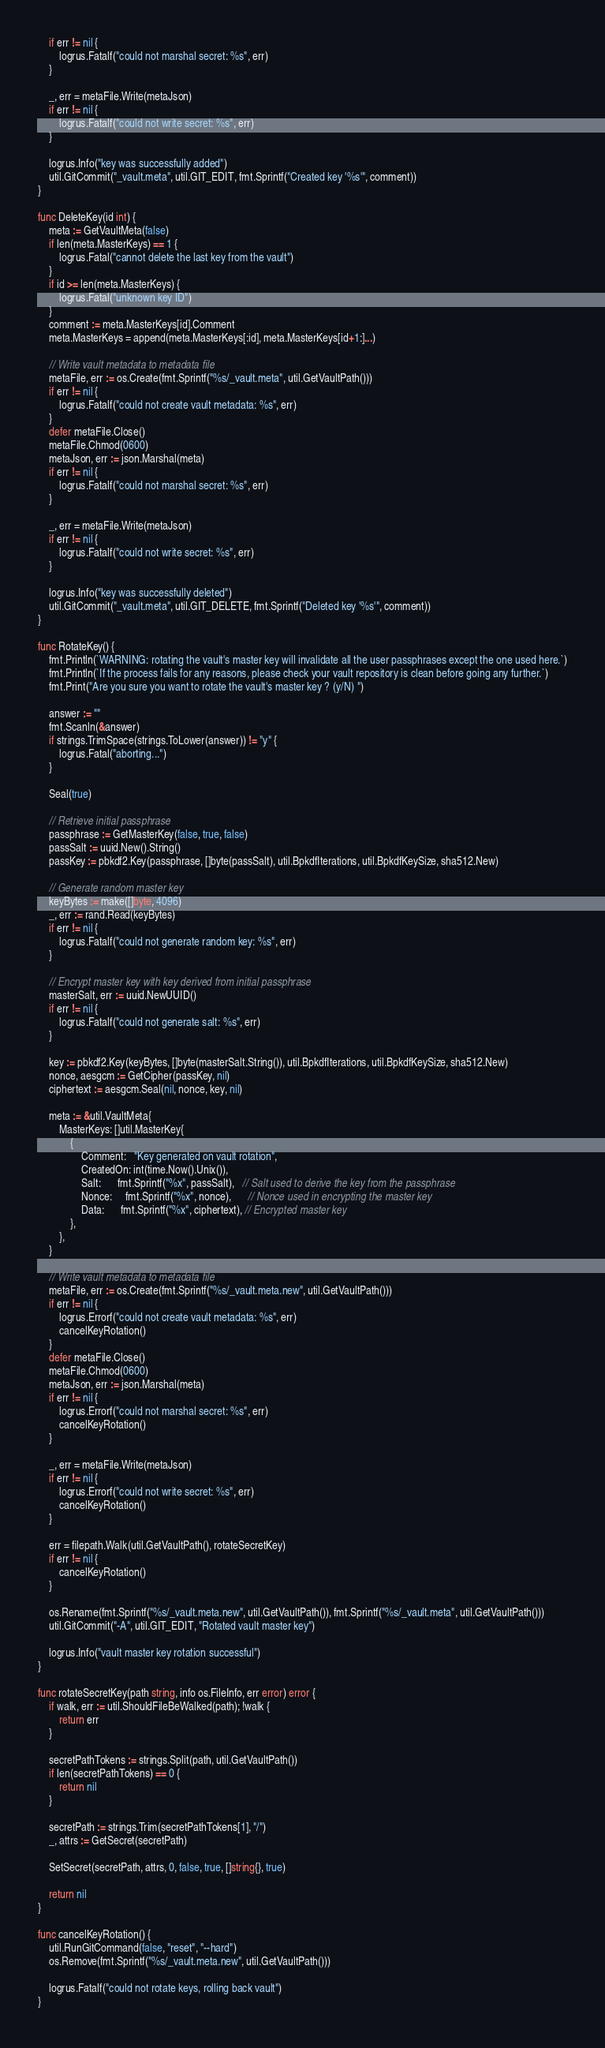<code> <loc_0><loc_0><loc_500><loc_500><_Go_>	if err != nil {
		logrus.Fatalf("could not marshal secret: %s", err)
	}

	_, err = metaFile.Write(metaJson)
	if err != nil {
		logrus.Fatalf("could not write secret: %s", err)
	}

	logrus.Info("key was successfully added")
	util.GitCommit("_vault.meta", util.GIT_EDIT, fmt.Sprintf("Created key '%s'", comment))
}

func DeleteKey(id int) {
	meta := GetVaultMeta(false)
	if len(meta.MasterKeys) == 1 {
		logrus.Fatal("cannot delete the last key from the vault")
	}
	if id >= len(meta.MasterKeys) {
		logrus.Fatal("unknown key ID")
	}
	comment := meta.MasterKeys[id].Comment
	meta.MasterKeys = append(meta.MasterKeys[:id], meta.MasterKeys[id+1:]...)

	// Write vault metadata to metadata file
	metaFile, err := os.Create(fmt.Sprintf("%s/_vault.meta", util.GetVaultPath()))
	if err != nil {
		logrus.Fatalf("could not create vault metadata: %s", err)
	}
	defer metaFile.Close()
	metaFile.Chmod(0600)
	metaJson, err := json.Marshal(meta)
	if err != nil {
		logrus.Fatalf("could not marshal secret: %s", err)
	}

	_, err = metaFile.Write(metaJson)
	if err != nil {
		logrus.Fatalf("could not write secret: %s", err)
	}

	logrus.Info("key was successfully deleted")
	util.GitCommit("_vault.meta", util.GIT_DELETE, fmt.Sprintf("Deleted key '%s'", comment))
}

func RotateKey() {
	fmt.Println(`WARNING: rotating the vault's master key will invalidate all the user passphrases except the one used here.`)
	fmt.Println(`If the process fails for any reasons, please check your vault repository is clean before going any further.`)
	fmt.Print("Are you sure you want to rotate the vault's master key ? (y/N) ")

	answer := ""
	fmt.Scanln(&answer)
	if strings.TrimSpace(strings.ToLower(answer)) != "y" {
		logrus.Fatal("aborting...")
	}

	Seal(true)

	// Retrieve initial passphrase
	passphrase := GetMasterKey(false, true, false)
	passSalt := uuid.New().String()
	passKey := pbkdf2.Key(passphrase, []byte(passSalt), util.BpkdfIterations, util.BpkdfKeySize, sha512.New)

	// Generate random master key
	keyBytes := make([]byte, 4096)
	_, err := rand.Read(keyBytes)
	if err != nil {
		logrus.Fatalf("could not generate random key: %s", err)
	}

	// Encrypt master key with key derived from initial passphrase
	masterSalt, err := uuid.NewUUID()
	if err != nil {
		logrus.Fatalf("could not generate salt: %s", err)
	}

	key := pbkdf2.Key(keyBytes, []byte(masterSalt.String()), util.BpkdfIterations, util.BpkdfKeySize, sha512.New)
	nonce, aesgcm := GetCipher(passKey, nil)
	ciphertext := aesgcm.Seal(nil, nonce, key, nil)

	meta := &util.VaultMeta{
		MasterKeys: []util.MasterKey{
			{
				Comment:   "Key generated on vault rotation",
				CreatedOn: int(time.Now().Unix()),
				Salt:      fmt.Sprintf("%x", passSalt),   // Salt used to derive the key from the passphrase
				Nonce:     fmt.Sprintf("%x", nonce),      // Nonce used in encrypting the master key
				Data:      fmt.Sprintf("%x", ciphertext), // Encrypted master key
			},
		},
	}

	// Write vault metadata to metadata file
	metaFile, err := os.Create(fmt.Sprintf("%s/_vault.meta.new", util.GetVaultPath()))
	if err != nil {
		logrus.Errorf("could not create vault metadata: %s", err)
		cancelKeyRotation()
	}
	defer metaFile.Close()
	metaFile.Chmod(0600)
	metaJson, err := json.Marshal(meta)
	if err != nil {
		logrus.Errorf("could not marshal secret: %s", err)
		cancelKeyRotation()
	}

	_, err = metaFile.Write(metaJson)
	if err != nil {
		logrus.Errorf("could not write secret: %s", err)
		cancelKeyRotation()
	}

	err = filepath.Walk(util.GetVaultPath(), rotateSecretKey)
	if err != nil {
		cancelKeyRotation()
	}

	os.Rename(fmt.Sprintf("%s/_vault.meta.new", util.GetVaultPath()), fmt.Sprintf("%s/_vault.meta", util.GetVaultPath()))
	util.GitCommit("-A", util.GIT_EDIT, "Rotated vault master key")

	logrus.Info("vault master key rotation successful")
}

func rotateSecretKey(path string, info os.FileInfo, err error) error {
	if walk, err := util.ShouldFileBeWalked(path); !walk {
		return err
	}

	secretPathTokens := strings.Split(path, util.GetVaultPath())
	if len(secretPathTokens) == 0 {
		return nil
	}

	secretPath := strings.Trim(secretPathTokens[1], "/")
	_, attrs := GetSecret(secretPath)

	SetSecret(secretPath, attrs, 0, false, true, []string{}, true)

	return nil
}

func cancelKeyRotation() {
	util.RunGitCommand(false, "reset", "--hard")
	os.Remove(fmt.Sprintf("%s/_vault.meta.new", util.GetVaultPath()))

	logrus.Fatalf("could not rotate keys, rolling back vault")
}
</code> 